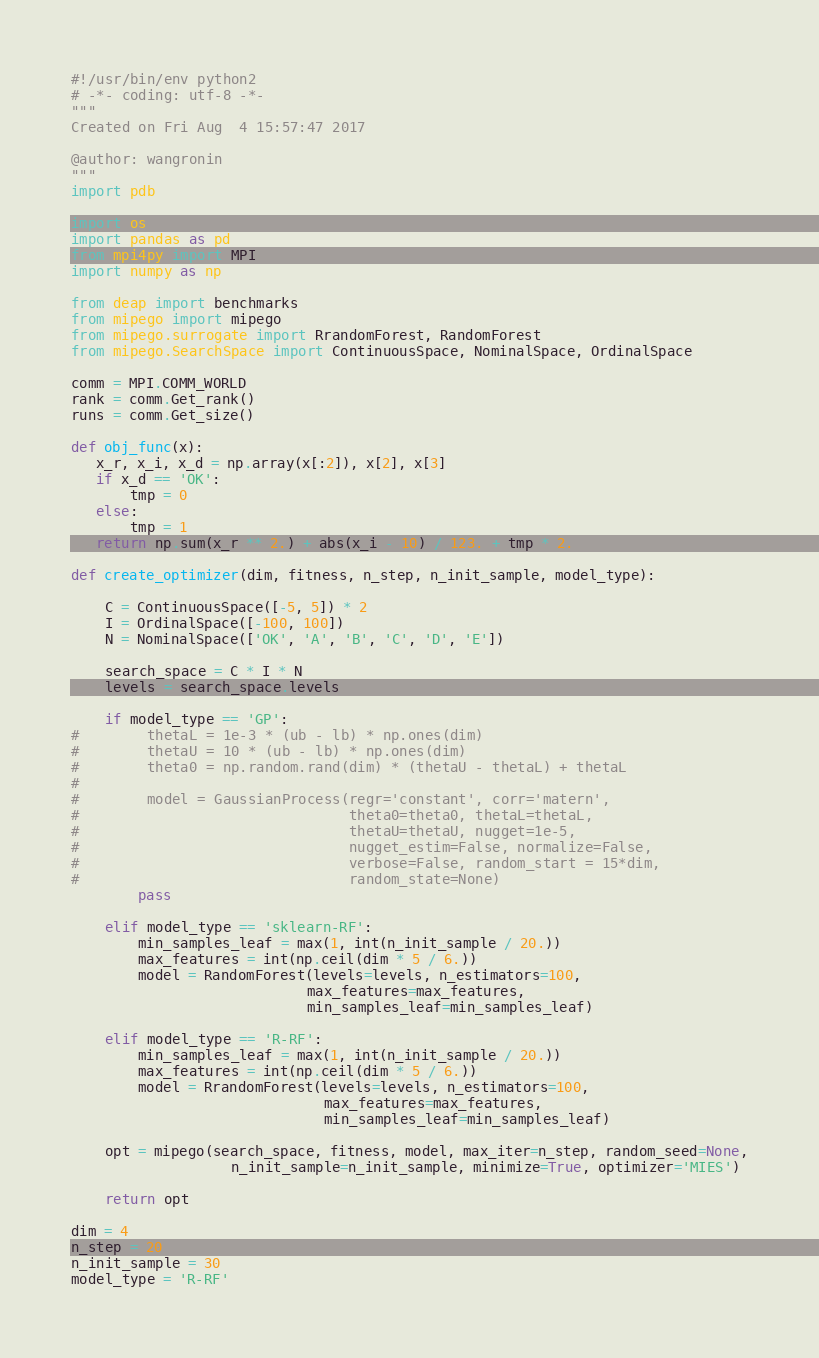<code> <loc_0><loc_0><loc_500><loc_500><_Python_>#!/usr/bin/env python2
# -*- coding: utf-8 -*-
"""
Created on Fri Aug  4 15:57:47 2017

@author: wangronin
"""
import pdb

import os
import pandas as pd
from mpi4py import MPI
import numpy as np

from deap import benchmarks
from mipego import mipego
from mipego.surrogate import RrandomForest, RandomForest
from mipego.SearchSpace import ContinuousSpace, NominalSpace, OrdinalSpace

comm = MPI.COMM_WORLD
rank = comm.Get_rank()
runs = comm.Get_size()

def obj_func(x):
   x_r, x_i, x_d = np.array(x[:2]), x[2], x[3]
   if x_d == 'OK':
       tmp = 0
   else:
       tmp = 1
   return np.sum(x_r ** 2.) + abs(x_i - 10) / 123. + tmp * 2.

def create_optimizer(dim, fitness, n_step, n_init_sample, model_type):

    C = ContinuousSpace([-5, 5]) * 2
    I = OrdinalSpace([-100, 100])
    N = NominalSpace(['OK', 'A', 'B', 'C', 'D', 'E'])

    search_space = C * I * N
    levels = search_space.levels
    
    if model_type == 'GP':
#        thetaL = 1e-3 * (ub - lb) * np.ones(dim)
#        thetaU = 10 * (ub - lb) * np.ones(dim)
#        theta0 = np.random.rand(dim) * (thetaU - thetaL) + thetaL
#    
#        model = GaussianProcess(regr='constant', corr='matern',
#                                theta0=theta0, thetaL=thetaL,
#                                thetaU=thetaU, nugget=1e-5,
#                                nugget_estim=False, normalize=False,
#                                verbose=False, random_start = 15*dim,
#                                random_state=None)
        pass
                               
    elif model_type == 'sklearn-RF':
        min_samples_leaf = max(1, int(n_init_sample / 20.))
        max_features = int(np.ceil(dim * 5 / 6.))
        model = RandomForest(levels=levels, n_estimators=100,
                            max_features=max_features,
                            min_samples_leaf=min_samples_leaf)

    elif model_type == 'R-RF':
        min_samples_leaf = max(1, int(n_init_sample / 20.))
        max_features = int(np.ceil(dim * 5 / 6.))
        model = RrandomForest(levels=levels, n_estimators=100, 
                              max_features=max_features,
                              min_samples_leaf=min_samples_leaf)

    opt = mipego(search_space, fitness, model, max_iter=n_step, random_seed=None,
                   n_init_sample=n_init_sample, minimize=True, optimizer='MIES')
    
    return opt

dim = 4
n_step = 20
n_init_sample = 30
model_type = 'R-RF'</code> 